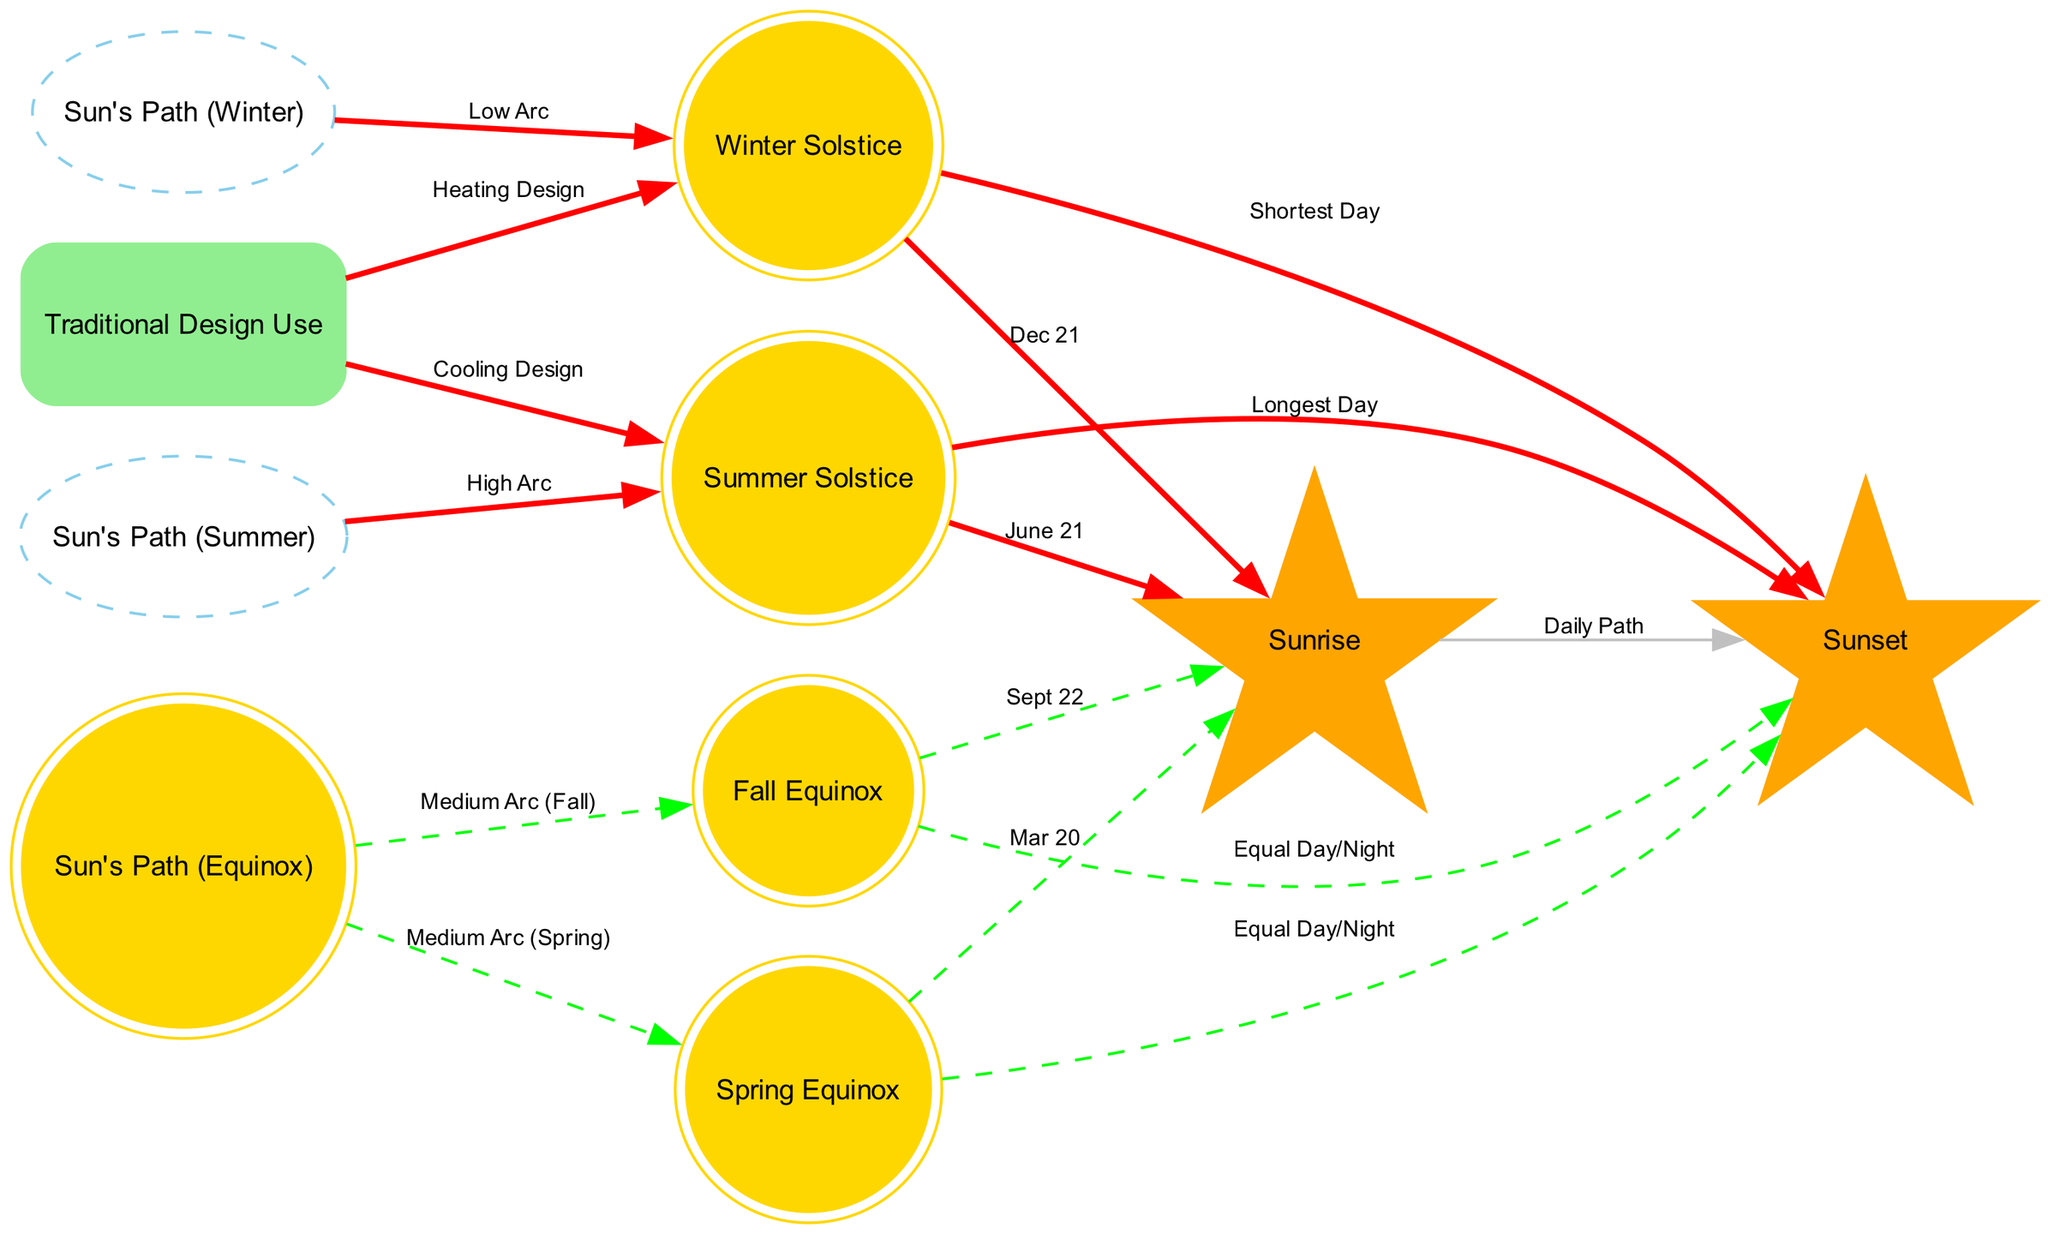What is the label of the node representing the longest day? The diagram includes a node labeled "Longest Day" as a result of the connection from the "Summer Solstice" node, indicating the date of the summer solstice corresponds to the longest day of the year.
Answer: Longest Day Which path has the highest arc? By analyzing the diagram, the "High Arc" is connected to the "Sun's Path (Summer)" node, indicating that the sun takes the highest trajectory in the sky during summer.
Answer: High Arc How many seasonal events are represented in the diagram? The nodes for seasonal events are: "Summer Solstice," "Winter Solstice," "Spring Equinox," and "Fall Equinox." There are four distinct nodes that represent these events.
Answer: 4 What is the relationship between the winter solstice and the shortest day? The diagram shows a direct connection labeled "Shortest Day" from the "Winter Solstice" node, indicating that the shortest day occurs at the winter solstice.
Answer: Shortest Day During which equinox does the sun's path have a medium arc? The diagram indicates that both the "Spring Equinox" and "Fall Equinox" nodes are connected to the "Sun's Path (Equinox)" node, where it is described to have a medium arc.
Answer: Medium Arc What is the design purpose associated with the winter solstice? Observing the connections in the diagram, the label "Heating Design" is linked to the "Winter Solstice," suggesting traditional architectural approaches to utilize sunlight for heating during winter.
Answer: Heating Design Which nodes connect to the sunrise? The diagram shows connections from the "Sunrise" node to "Sunset," "Summer Solstice," "Spring Equinox," and "Fall Equinox," indicating it relates to various time points in conjunction with sunrise.
Answer: Sunset, Summer Solstice, Spring Equinox, Fall Equinox Which label corresponds to the date March 20? The node "Mar 20" directly connects to "Spring Equinox," showing that March 20 corresponds to the spring equinox in the diagram.
Answer: Spring Equinox 